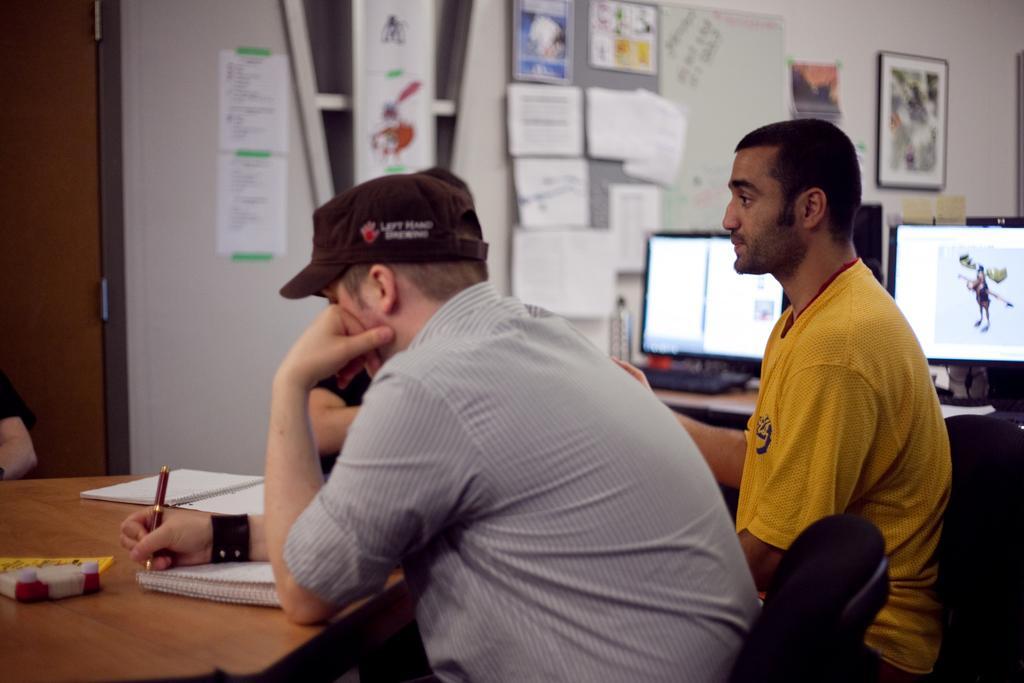Please provide a concise description of this image. In the image we can see four persons were sitting on the chair around the table. On table we can see pen,books and toy. In the background there is a table,monitors,bottles,papers,wall,door and photo frames. 